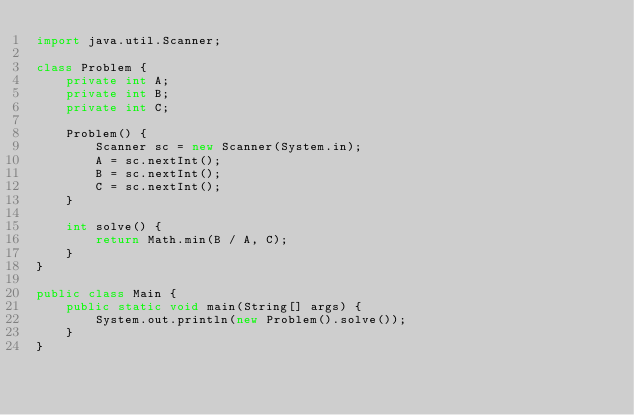Convert code to text. <code><loc_0><loc_0><loc_500><loc_500><_Java_>import java.util.Scanner;

class Problem {
    private int A;
    private int B;
    private int C;

    Problem() {
        Scanner sc = new Scanner(System.in);
        A = sc.nextInt();
        B = sc.nextInt();
        C = sc.nextInt();
    }

    int solve() {
        return Math.min(B / A, C);
    }
}

public class Main {
    public static void main(String[] args) {
        System.out.println(new Problem().solve());
    }
}
</code> 